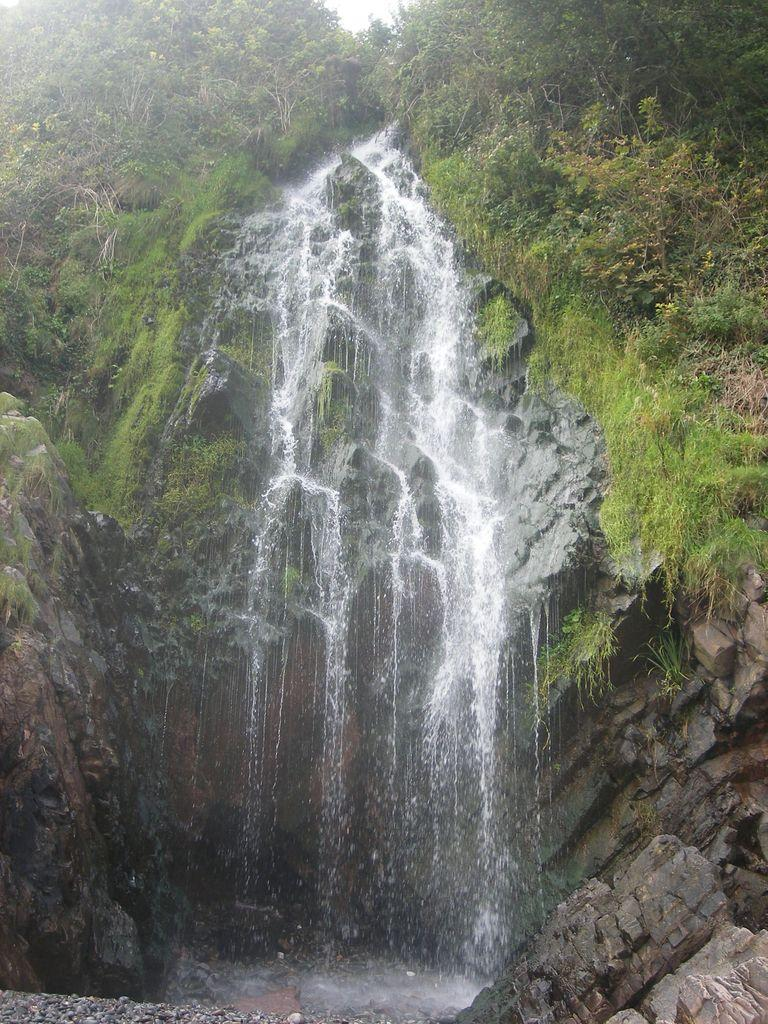What natural feature is the main subject of the image? There is a waterfall in the image. What type of vegetation can be seen on the right side of the image? There are plants on the right side of the image. What type of vegetation can be seen on the left side of the image? There are plants on the left side of the image. What geological feature is present at the right bottom of the image? There is a rock at the right bottom of the image. What type of winter sport is being played in the image? There is no winter sport or any indication of winter in the image; it features a waterfall, plants, and a rock. What channel is the waterfall flowing into in the image? The image does not show the waterfall flowing into a specific channel; it only shows the waterfall itself. 